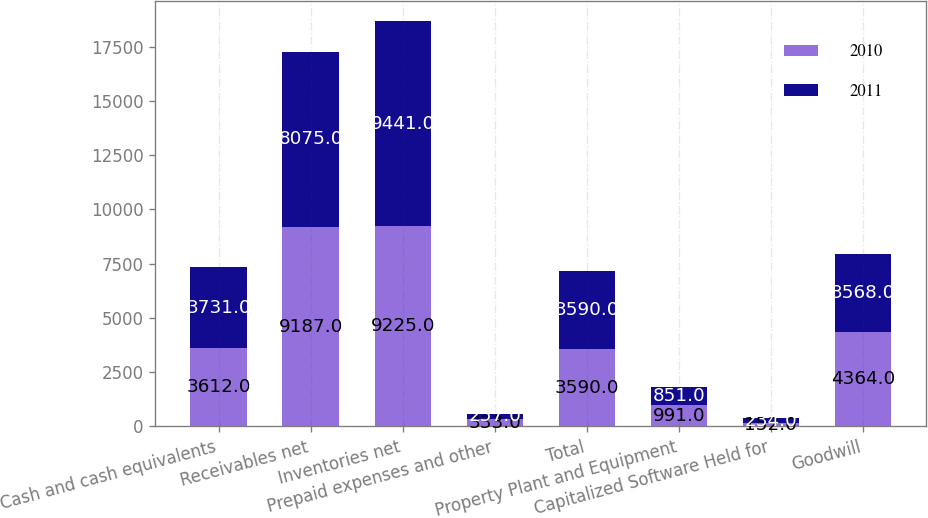Convert chart. <chart><loc_0><loc_0><loc_500><loc_500><stacked_bar_chart><ecel><fcel>Cash and cash equivalents<fcel>Receivables net<fcel>Inventories net<fcel>Prepaid expenses and other<fcel>Total<fcel>Property Plant and Equipment<fcel>Capitalized Software Held for<fcel>Goodwill<nl><fcel>2010<fcel>3612<fcel>9187<fcel>9225<fcel>333<fcel>3590<fcel>991<fcel>152<fcel>4364<nl><fcel>2011<fcel>3731<fcel>8075<fcel>9441<fcel>257<fcel>3590<fcel>851<fcel>234<fcel>3568<nl></chart> 